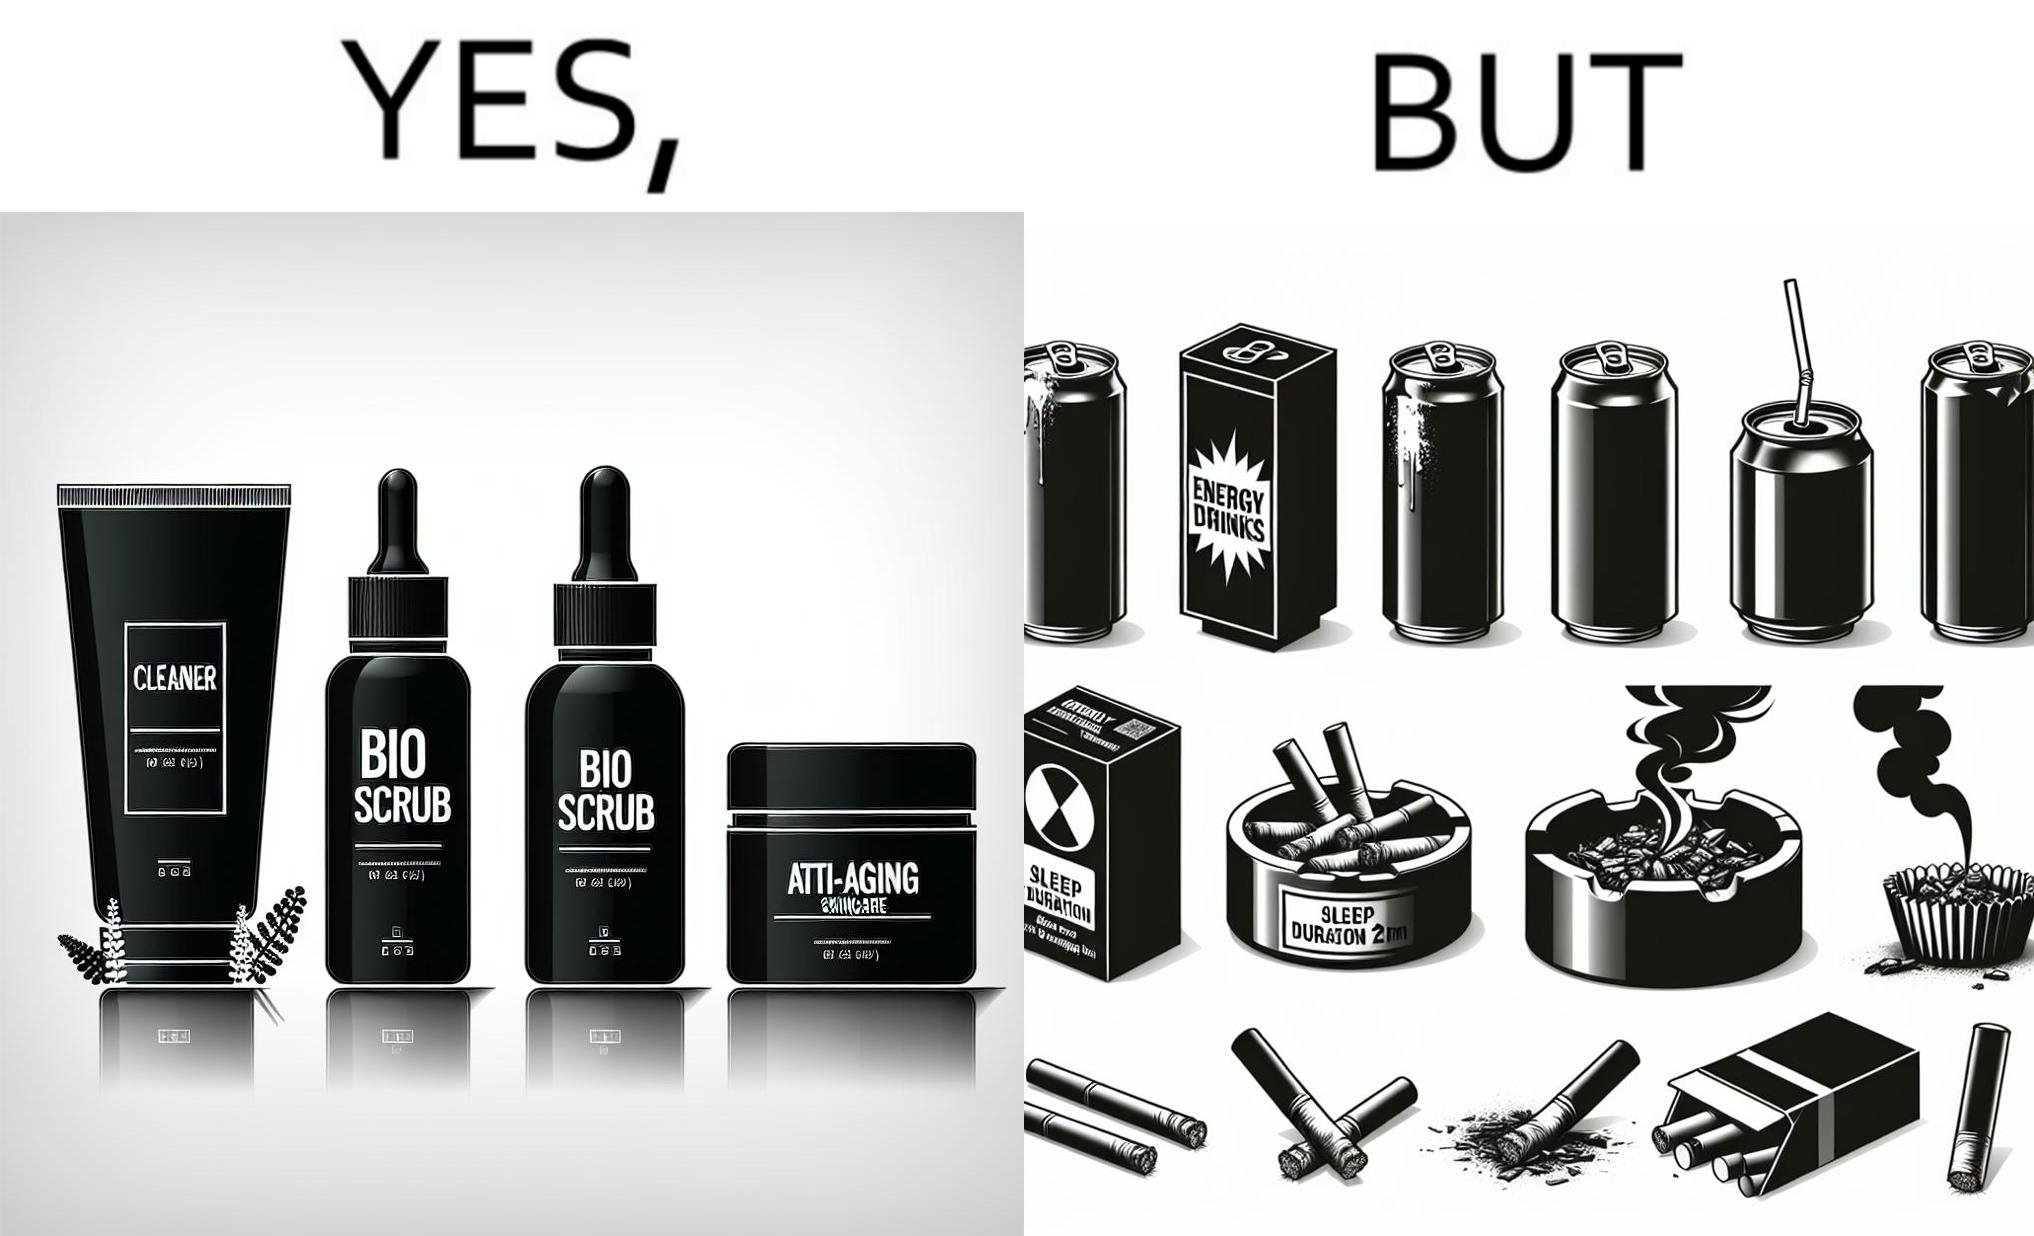What makes this image funny or satirical? This image is ironic as on the one hand, the presumed person is into skincare and wants to do the best for their skin, which is good, but on the other hand, they are involved in unhealthy habits that will damage their skin like smoking, caffeine and inadequate sleep. 